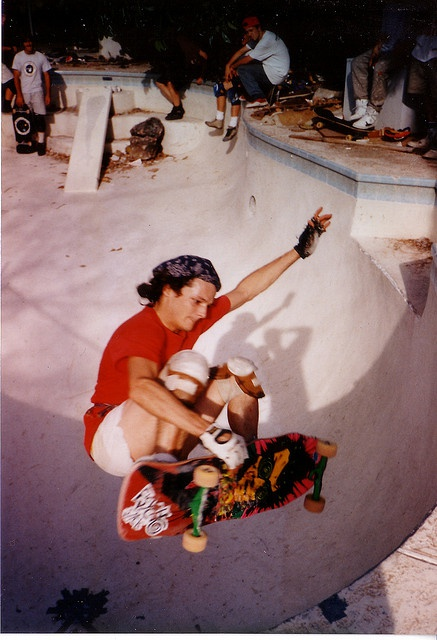Describe the objects in this image and their specific colors. I can see people in white, brown, tan, salmon, and black tones, skateboard in white, black, maroon, and brown tones, people in white, black, maroon, darkgray, and gray tones, people in white, black, maroon, darkgray, and gray tones, and people in white, black, maroon, and gray tones in this image. 